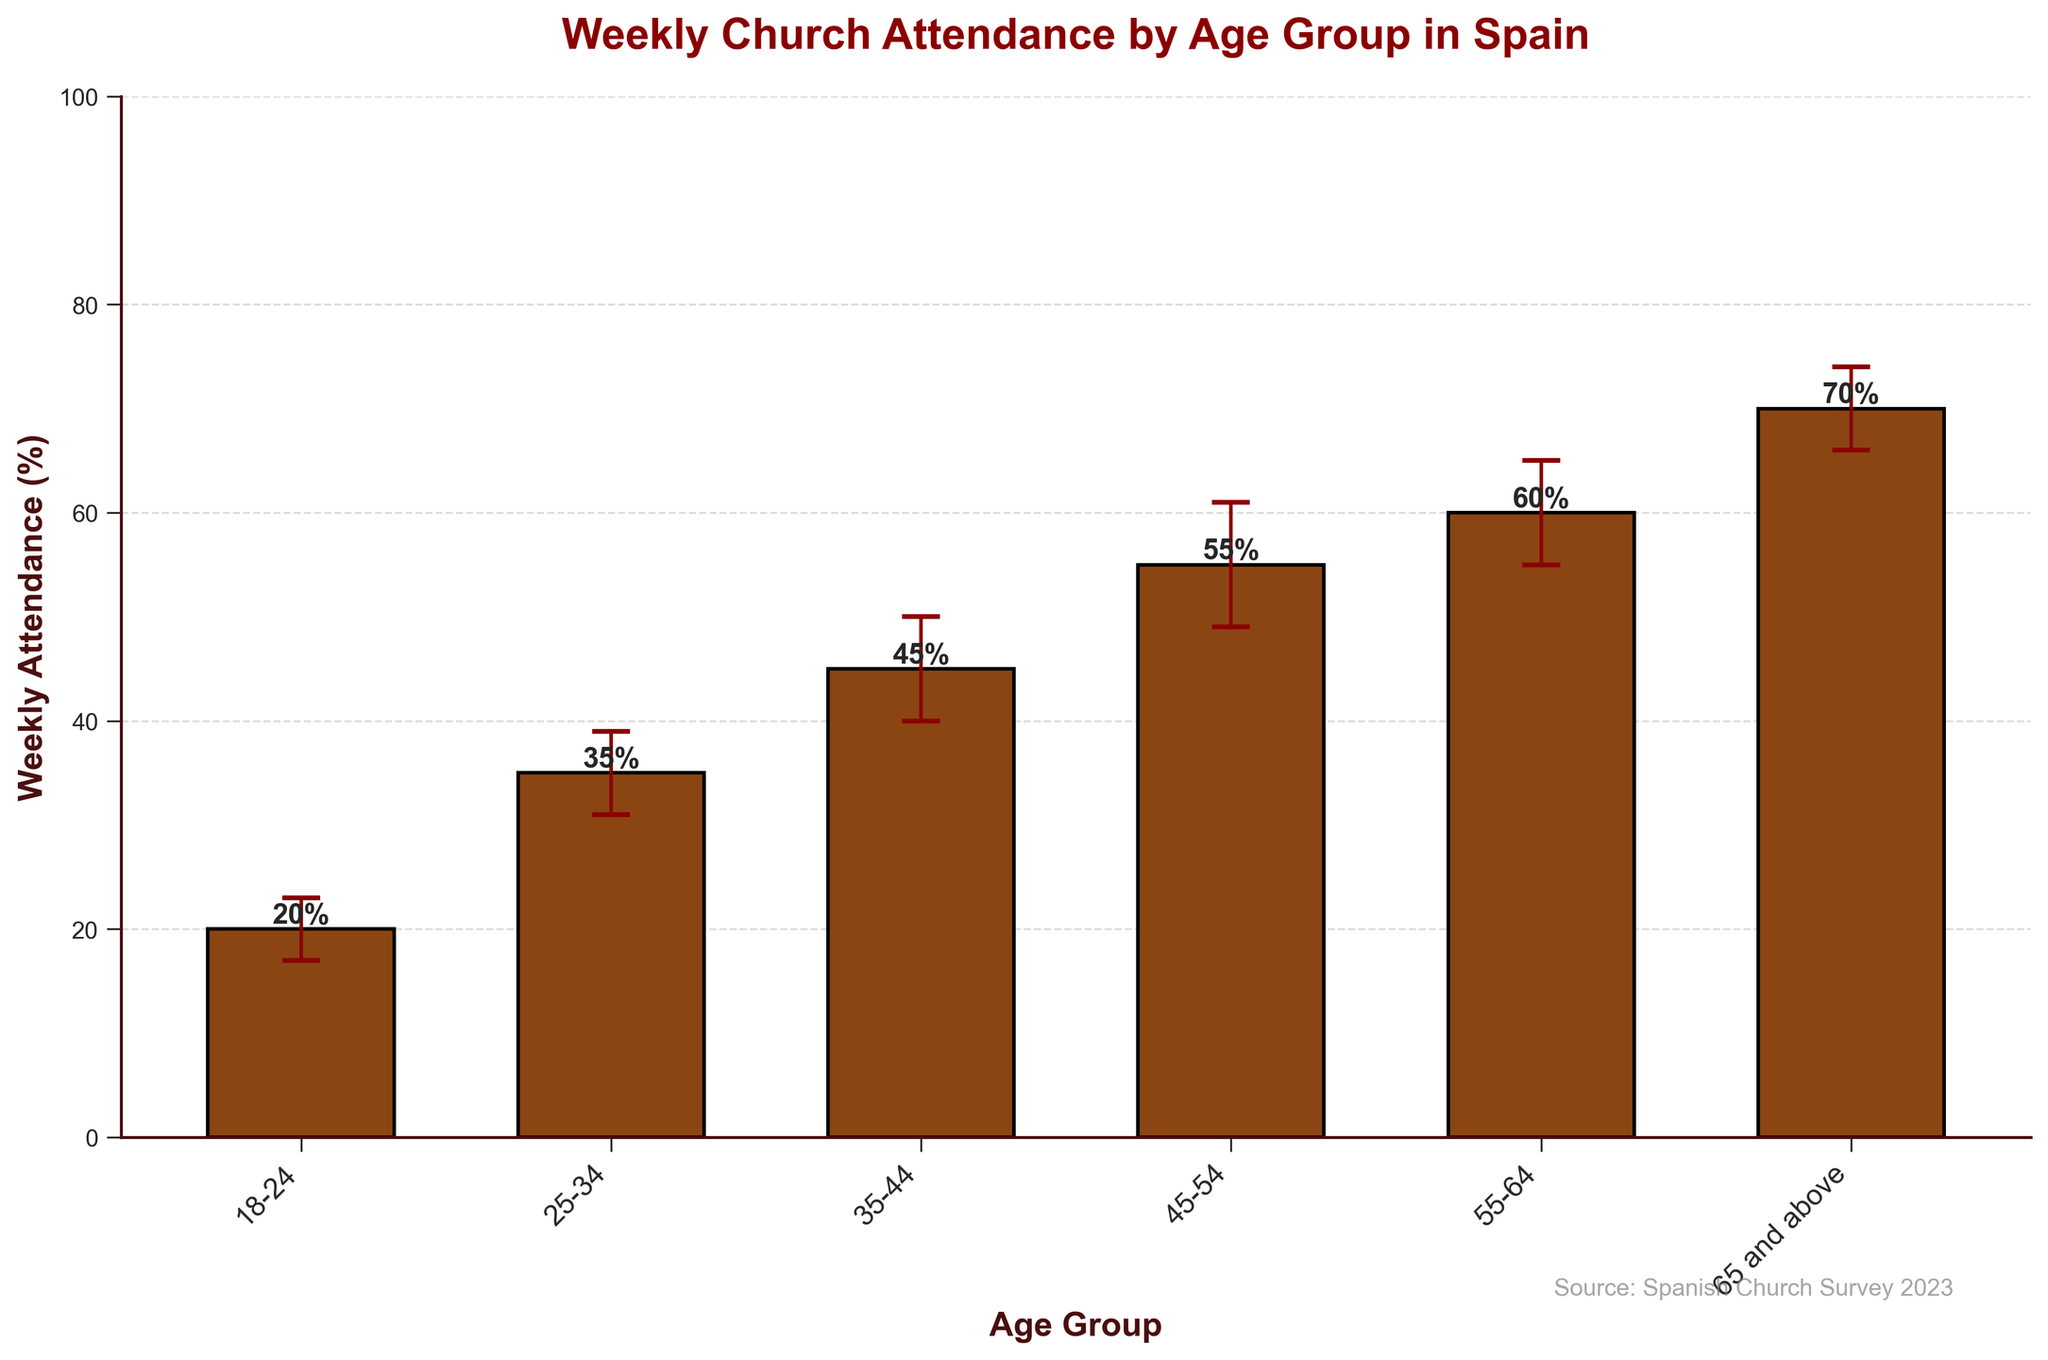What's the title of the bar chart? The title is prominently displayed at the top of the chart, providing a clear indication of the chart's subject matter.
Answer: Weekly Church Attendance by Age Group in Spain What is the percentage of weekly church attendance for the 25-34 age group? Locate the bar corresponding to the 25-34 age group and read the value at the top of the bar.
Answer: 35% Which age group has the highest weekly church attendance percentage? Compare the heights of the bars for each age group. The tallest bar represents the highest percentage.
Answer: 65 and above What is the error margin for the 18-24 age group? Find the error bar for the 18-24 age group and read the value indicated for the error margin.
Answer: 3% How much higher is the attendance for the 45-54 age group compared to the 18-24 age group? Subtract the attendance percentage of the 18-24 age group from that of the 45-54 age group. Specifically, subtract 20% from 55%.
Answer: 35% Which age group has the smallest error margin, and what is its value? Compare the values of the error margins for each age group and identify the smallest one.
Answer: 18-24, 3% What is the average weekly church attendance percentage across all age groups? Add up the weekly attendance percentages for all age groups and divide by the number of age groups. Specifically, (20 + 35 + 45 + 55 + 60 + 70) / 6.
Answer: 47.5% Between which two consecutive age groups is the largest increase in weekly church attendance observed? Calculate the differences in weekly attendance percentages for consecutive age groups and identify the pair with the largest difference.
Answer: 25-34 and 35-44 Which age group has an attendance percentage closest to 50%? Identify the age group whose attendance percentage is closest to 50% by comparing the values.
Answer: 45-54 Does any age group's bar overlap with the 50% attendance mark when considering the error margins? Check the error bars for each age group to see if any cover the 50% mark.
Answer: 45-54 